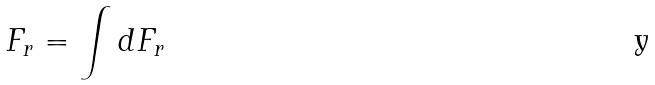<formula> <loc_0><loc_0><loc_500><loc_500>F _ { r } = \int d F _ { r }</formula> 